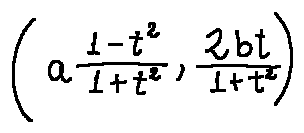<formula> <loc_0><loc_0><loc_500><loc_500>( a \frac { 1 - t ^ { 2 } } { 1 + t ^ { 2 } } , \frac { 2 b t } { 1 + t ^ { 2 } } )</formula> 